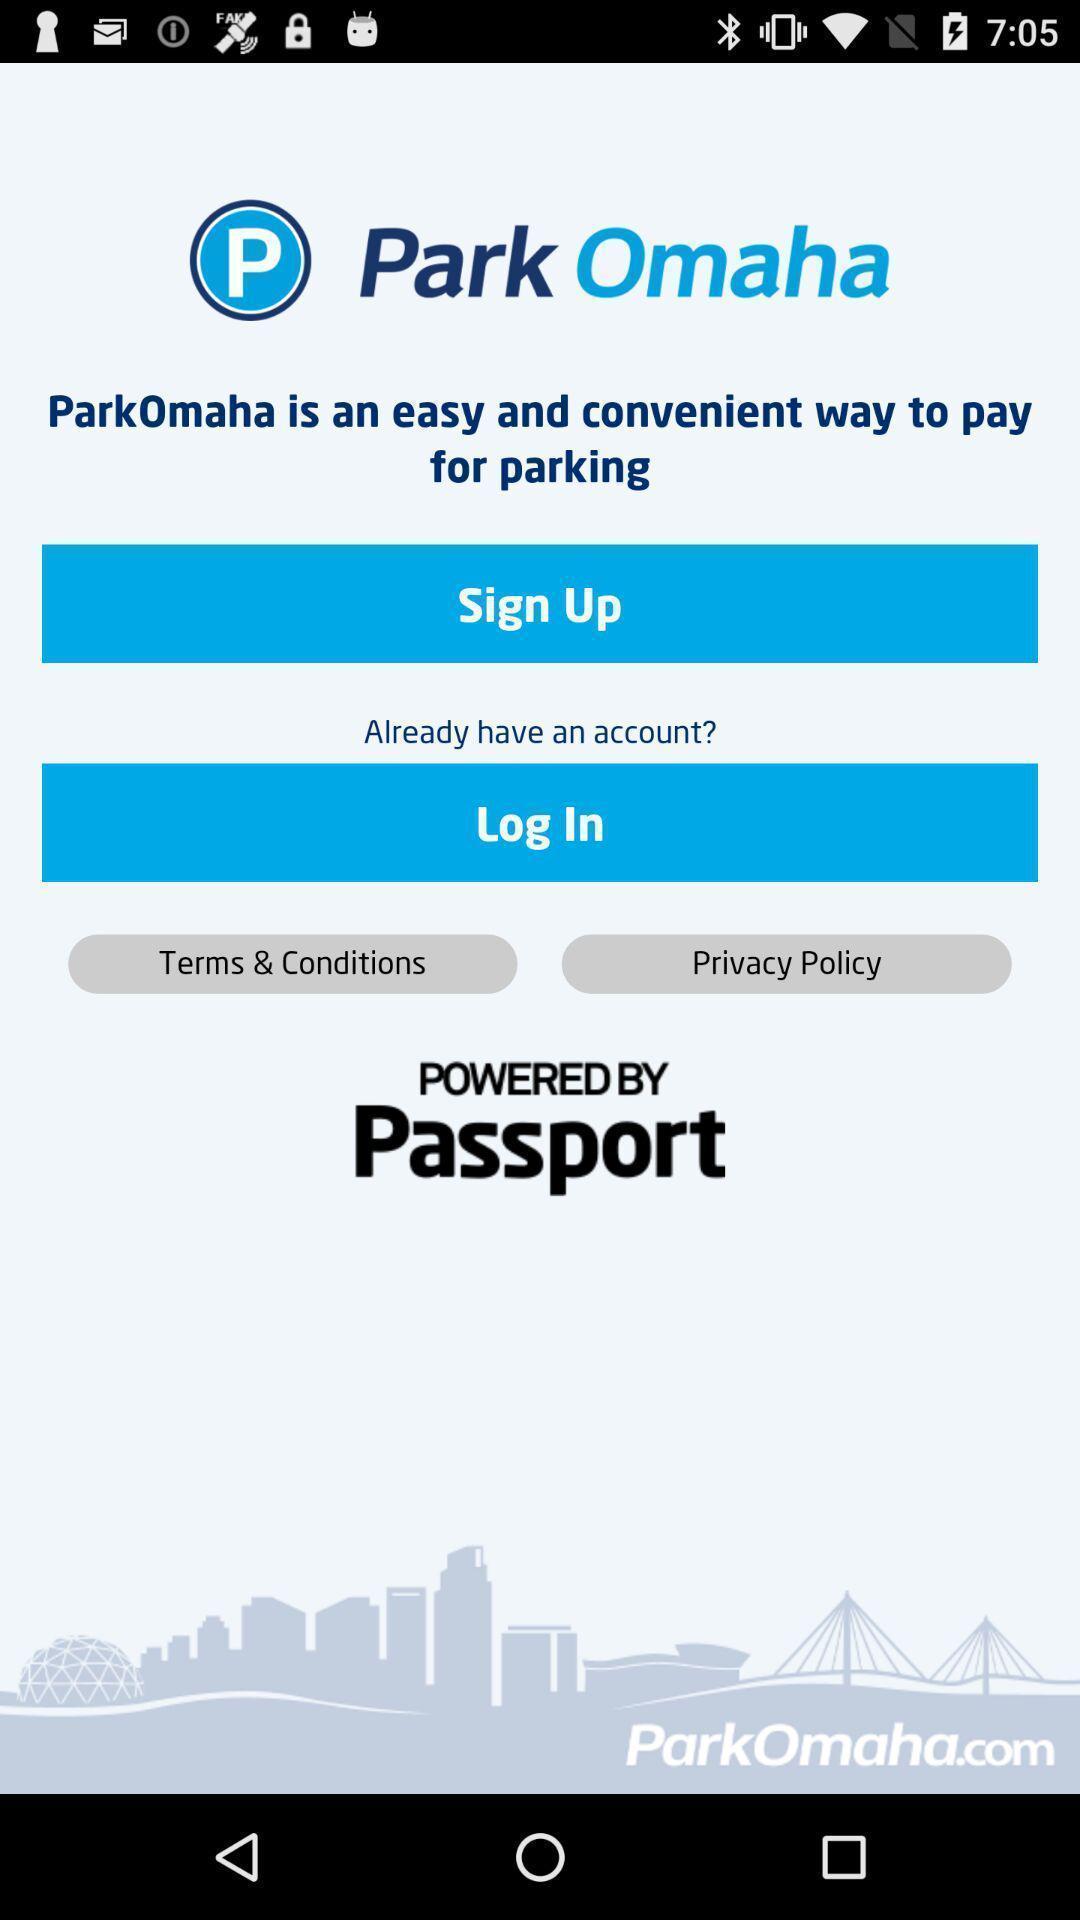Tell me what you see in this picture. Welcome page asking to login or signup. 